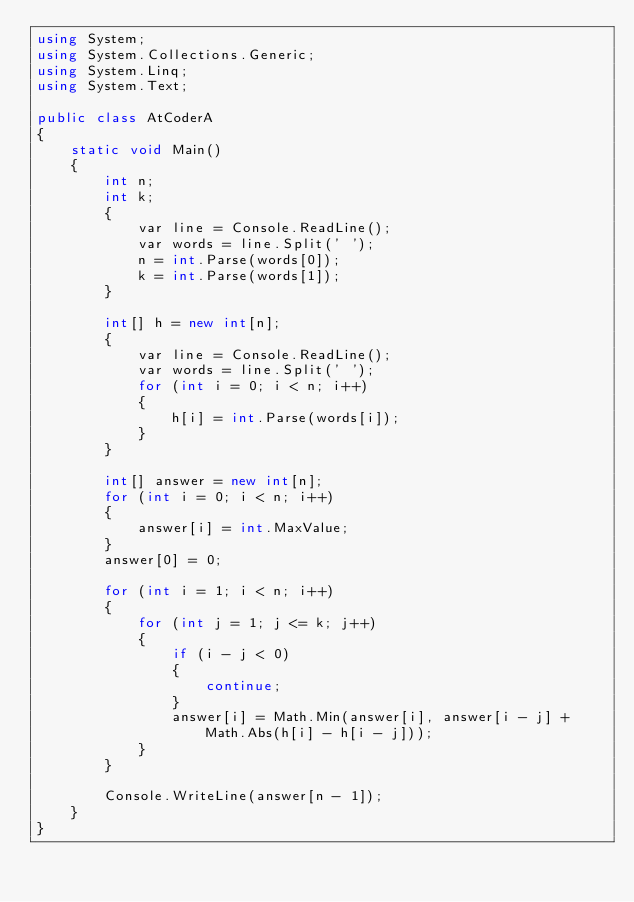<code> <loc_0><loc_0><loc_500><loc_500><_C#_>using System;
using System.Collections.Generic;
using System.Linq;
using System.Text;

public class AtCoderA
{
    static void Main()
    {
        int n;
        int k;
        {
            var line = Console.ReadLine();
            var words = line.Split(' ');
            n = int.Parse(words[0]);
            k = int.Parse(words[1]);
        }

        int[] h = new int[n];
        {
            var line = Console.ReadLine();
            var words = line.Split(' ');
            for (int i = 0; i < n; i++)
            {
                h[i] = int.Parse(words[i]);
            }
        }

        int[] answer = new int[n];
        for (int i = 0; i < n; i++)
        {
            answer[i] = int.MaxValue;
        }
        answer[0] = 0;

        for (int i = 1; i < n; i++)
        {
            for (int j = 1; j <= k; j++)
            {
                if (i - j < 0)
                {
                    continue;
                }
                answer[i] = Math.Min(answer[i], answer[i - j] + Math.Abs(h[i] - h[i - j]));
            }
        }

        Console.WriteLine(answer[n - 1]);
    }
}</code> 